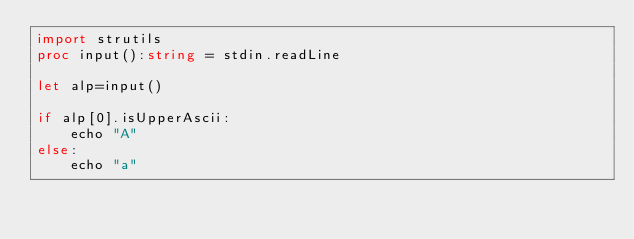Convert code to text. <code><loc_0><loc_0><loc_500><loc_500><_Nim_>import strutils
proc input():string = stdin.readLine

let alp=input()

if alp[0].isUpperAscii:
    echo "A"
else:
    echo "a"</code> 